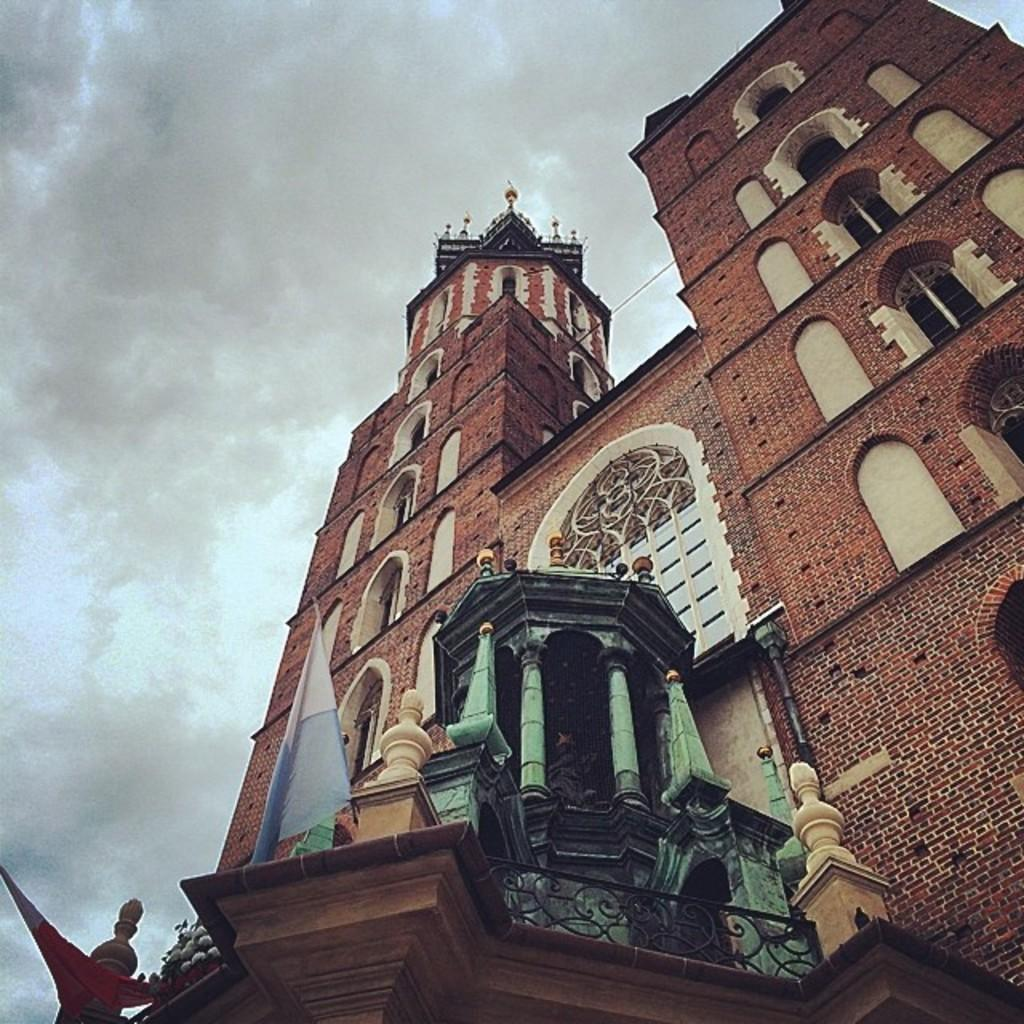What structure is present in the image? There is a building in the image. Are there any flags on the building? Yes, there are 2 flags on the building. What can be seen in the background of the image? The sky is visible in the background of the image. How would you describe the sky in the image? The sky appears to be cloudy. What type of insect is crawling on the roof of the building in the image? There is no insect visible on the roof of the building in the image. 